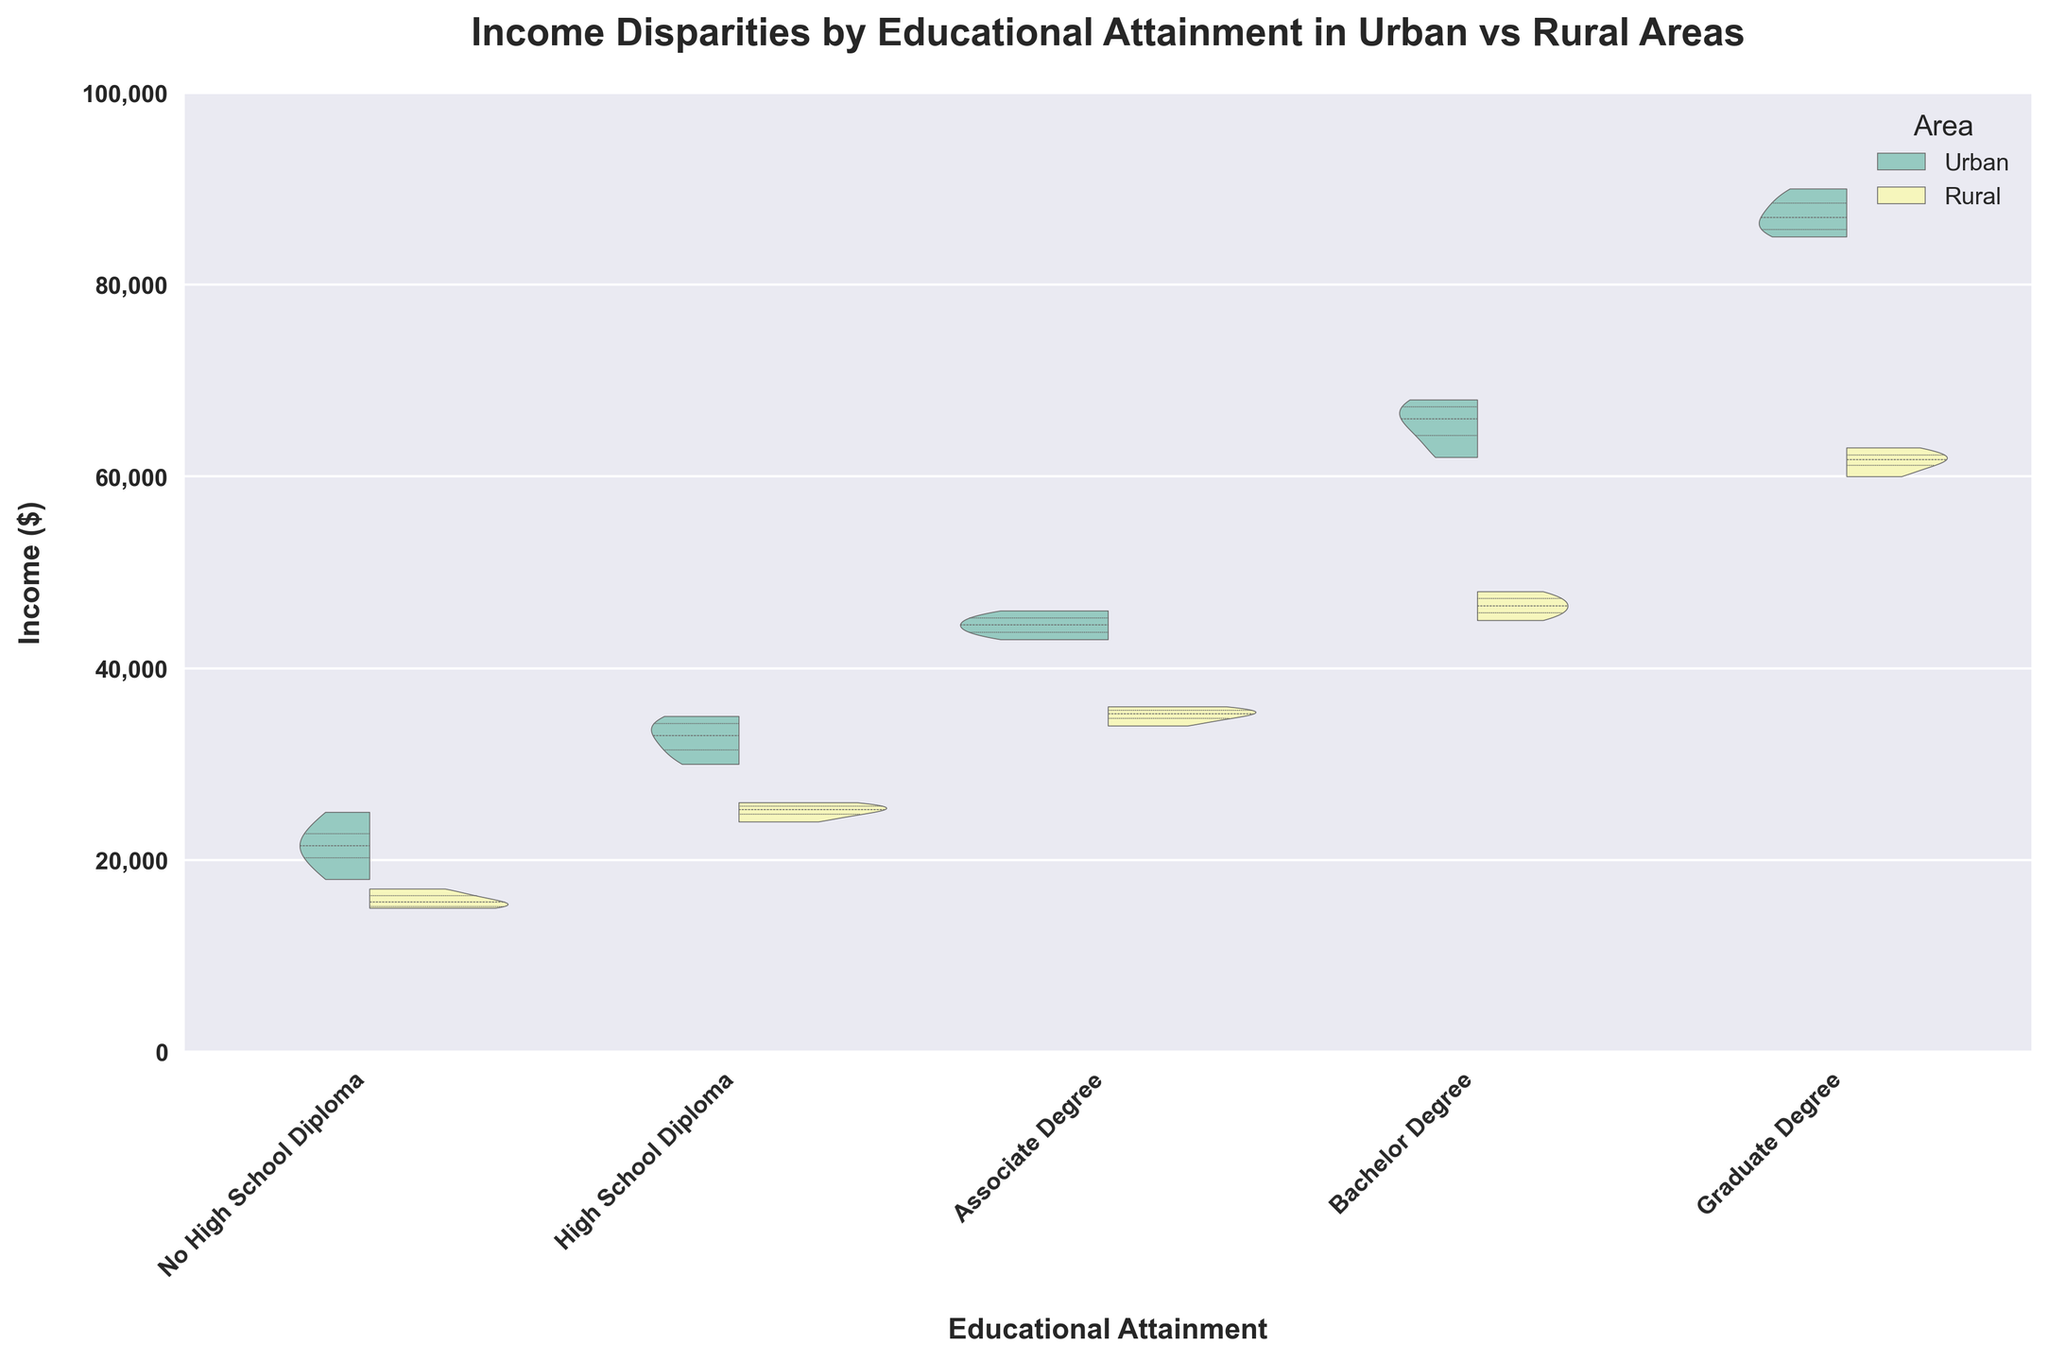What's the title of the figure? The title of the figure is written at the top, and it reads "Income Disparities by Educational Attainment in Urban vs Rural Areas".
Answer: Income Disparities by Educational Attainment in Urban vs Rural Areas What are the x-axis and y-axis labels? The x-axis label is "Educational Attainment" and the y-axis label is "Income ($)". These labels are shown at the bottom and left side of the figure respectively.
Answer: Educational Attainment; Income ($) How many categories of educational attainment are compared in the plot? The number of categories for educational attainment can be counted from the labels on the x-axis. There are five categories: No High School Diploma, High School Diploma, Associate Degree, Bachelor Degree, and Graduate Degree.
Answer: 5 Which area has the higher median income for the "Bachelor Degree" category? By observing the quartile lines within the violin plots for the "Bachelor Degree" category, the median line for Urban is higher than that for Rural.
Answer: Urban What is the general trend in income as educational attainment increases in urban areas? The violin plots show that as the level of educational attainment increases from "No High School Diploma" to "Graduate Degree", the incomes generally increase in urban areas, indicated by the upward shift in the distributions.
Answer: Income increases Is there a noticeable income disparity between urban and rural areas for individuals with an Associate Degree? By comparing the distributions for "Associate Degree," it is evident that urban areas have a higher income range compared to rural areas as the position of the violin plot for Urban is shifted higher than that for Rural.
Answer: Yes, urban areas have higher income What is the income range for individuals with a Graduate Degree in urban areas? The range of incomes can be estimated from the upper and lower bounds of the violin plot for the "Graduate Degree" category in urban areas. The income range roughly spans from $85,000 to $90,000.
Answer: $85,000 to $90,000 Which educational attainment category shows the largest spread in incomes within urban areas? The spread in incomes within a category can be assessed by observing the width of the violin plot. The "Graduate Degree" category in urban areas appears to have the widest distribution, indicating the largest spread.
Answer: Graduate Degree Between urban and rural areas, which has a steeper income rise from No High School Diploma to High School Diploma? By comparing the location shift of the quartile lines between "No High School Diploma" and "High School Diploma" categories for both areas, Urban shows a more noticeable increase in the income range than Rural.
Answer: Urban 